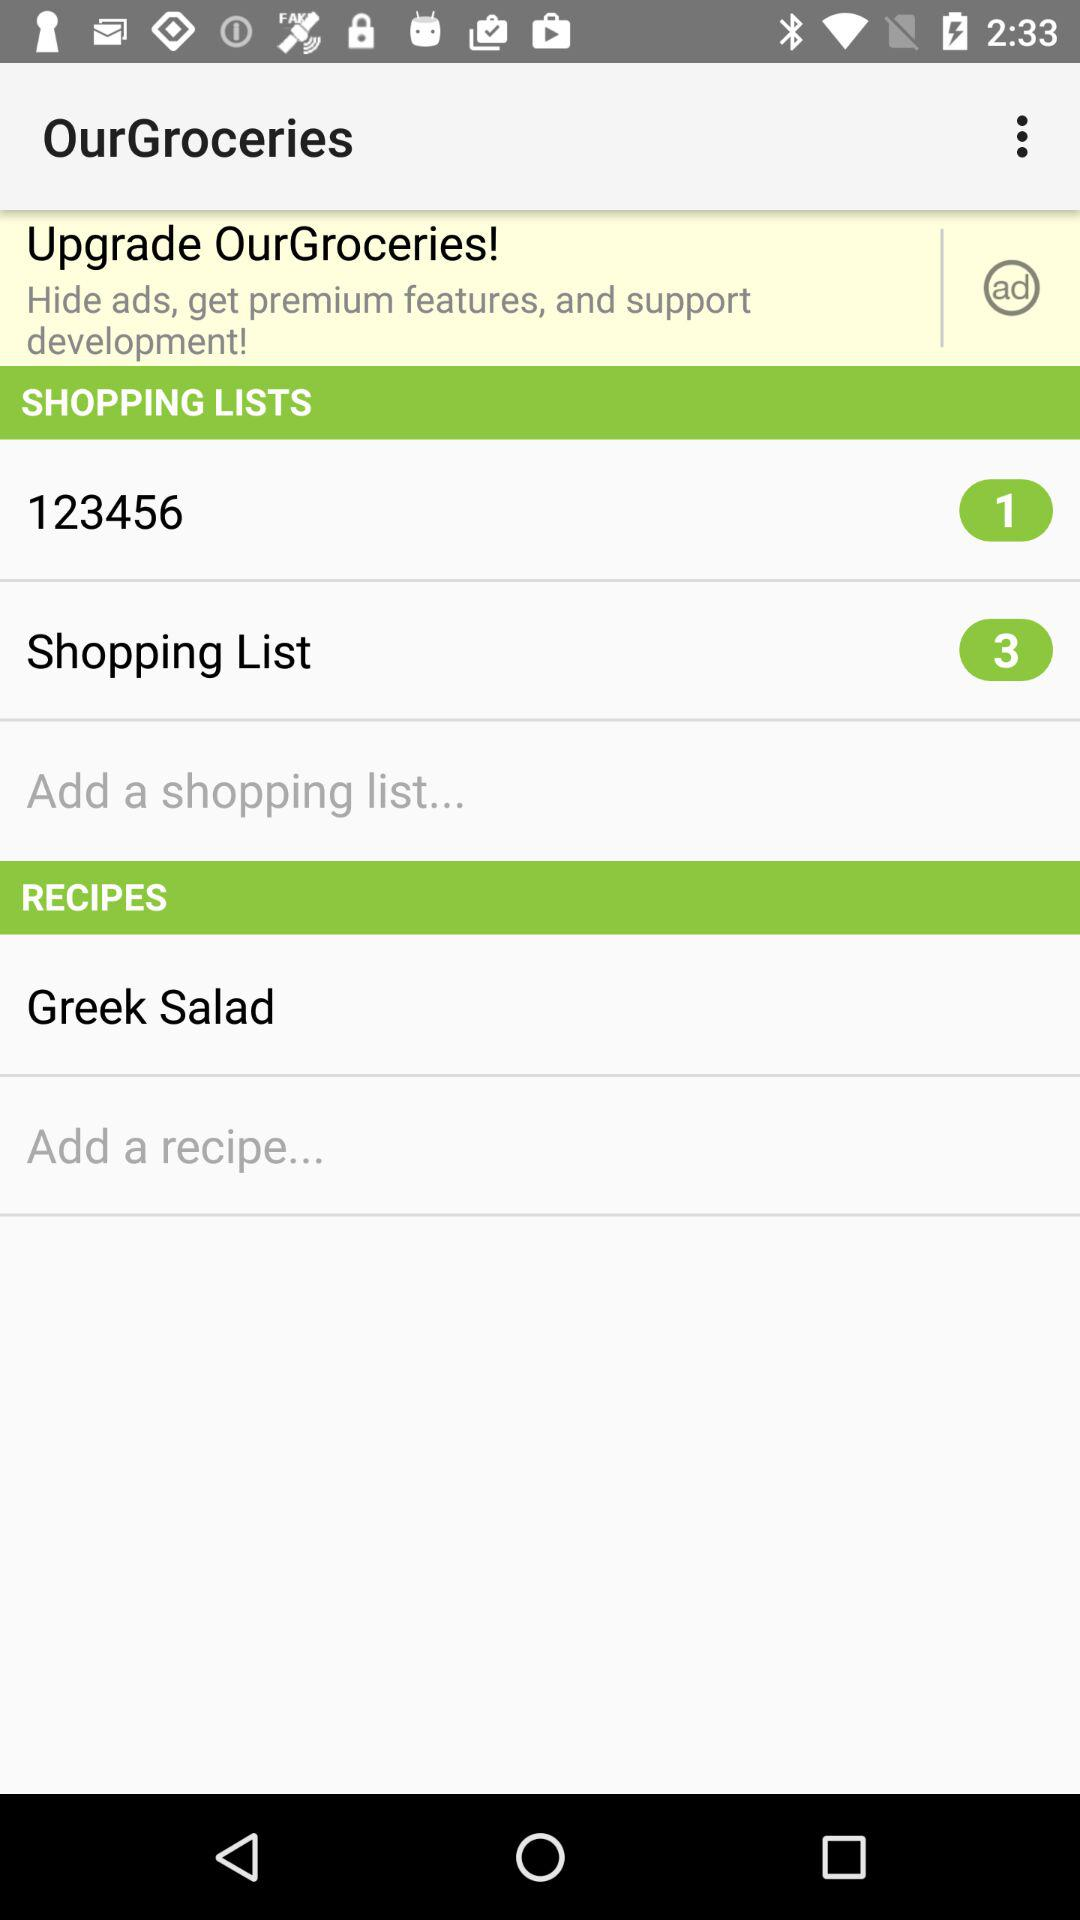What are the required ingredients for "Greek Salad"?
When the provided information is insufficient, respond with <no answer>. <no answer> 